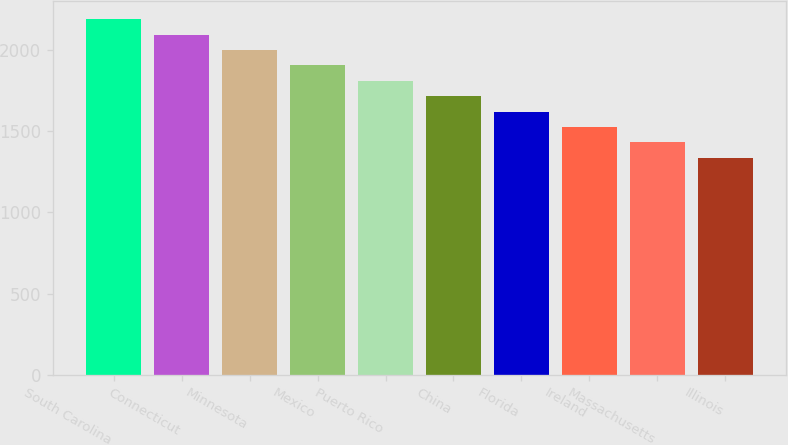<chart> <loc_0><loc_0><loc_500><loc_500><bar_chart><fcel>South Carolina<fcel>Connecticut<fcel>Minnesota<fcel>Mexico<fcel>Puerto Rico<fcel>China<fcel>Florida<fcel>Ireland<fcel>Massachusetts<fcel>Illinois<nl><fcel>2186.6<fcel>2092<fcel>1997.4<fcel>1902.8<fcel>1808.2<fcel>1713.6<fcel>1619<fcel>1524.4<fcel>1429.8<fcel>1335.2<nl></chart> 